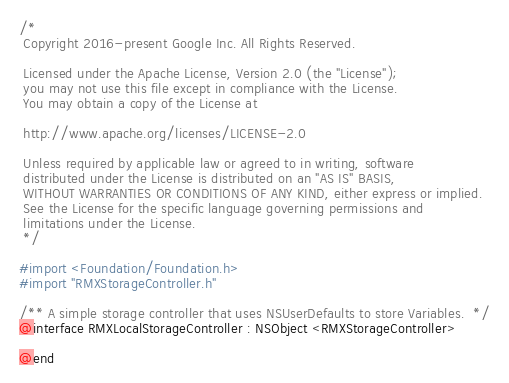Convert code to text. <code><loc_0><loc_0><loc_500><loc_500><_C_>/*
 Copyright 2016-present Google Inc. All Rights Reserved.

 Licensed under the Apache License, Version 2.0 (the "License");
 you may not use this file except in compliance with the License.
 You may obtain a copy of the License at

 http://www.apache.org/licenses/LICENSE-2.0

 Unless required by applicable law or agreed to in writing, software
 distributed under the License is distributed on an "AS IS" BASIS,
 WITHOUT WARRANTIES OR CONDITIONS OF ANY KIND, either express or implied.
 See the License for the specific language governing permissions and
 limitations under the License.
 */

#import <Foundation/Foundation.h>
#import "RMXStorageController.h"

/** A simple storage controller that uses NSUserDefaults to store Variables.  */
@interface RMXLocalStorageController : NSObject <RMXStorageController>

@end
</code> 